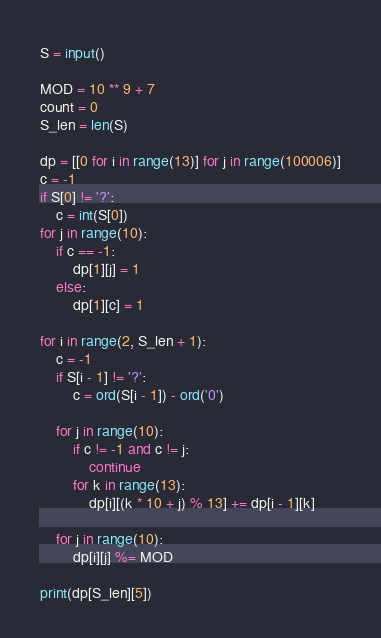Convert code to text. <code><loc_0><loc_0><loc_500><loc_500><_Python_>
S = input()

MOD = 10 ** 9 + 7
count = 0
S_len = len(S)

dp = [[0 for i in range(13)] for j in range(100006)]
c = -1
if S[0] != '?':
    c = int(S[0])
for j in range(10):
    if c == -1:
        dp[1][j] = 1
    else:
        dp[1][c] = 1

for i in range(2, S_len + 1):
    c = -1
    if S[i - 1] != '?':
        c = ord(S[i - 1]) - ord('0')

    for j in range(10):
        if c != -1 and c != j:
            continue
        for k in range(13):
            dp[i][(k * 10 + j) % 13] += dp[i - 1][k]

    for j in range(10):
        dp[i][j] %= MOD

print(dp[S_len][5])


</code> 